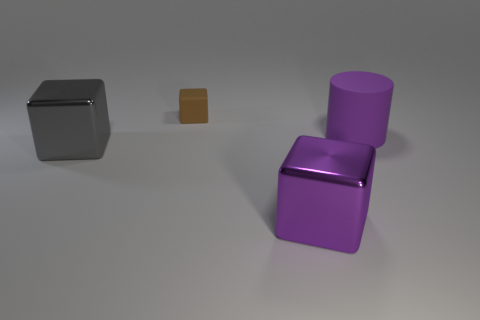Add 2 small cubes. How many objects exist? 6 Subtract all cylinders. How many objects are left? 3 Subtract all big green cubes. Subtract all small cubes. How many objects are left? 3 Add 4 large metallic blocks. How many large metallic blocks are left? 6 Add 3 brown cubes. How many brown cubes exist? 4 Subtract 0 gray balls. How many objects are left? 4 